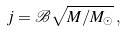Convert formula to latex. <formula><loc_0><loc_0><loc_500><loc_500>j = \mathcal { B } \sqrt { M / M _ { \odot } } \, ,</formula> 